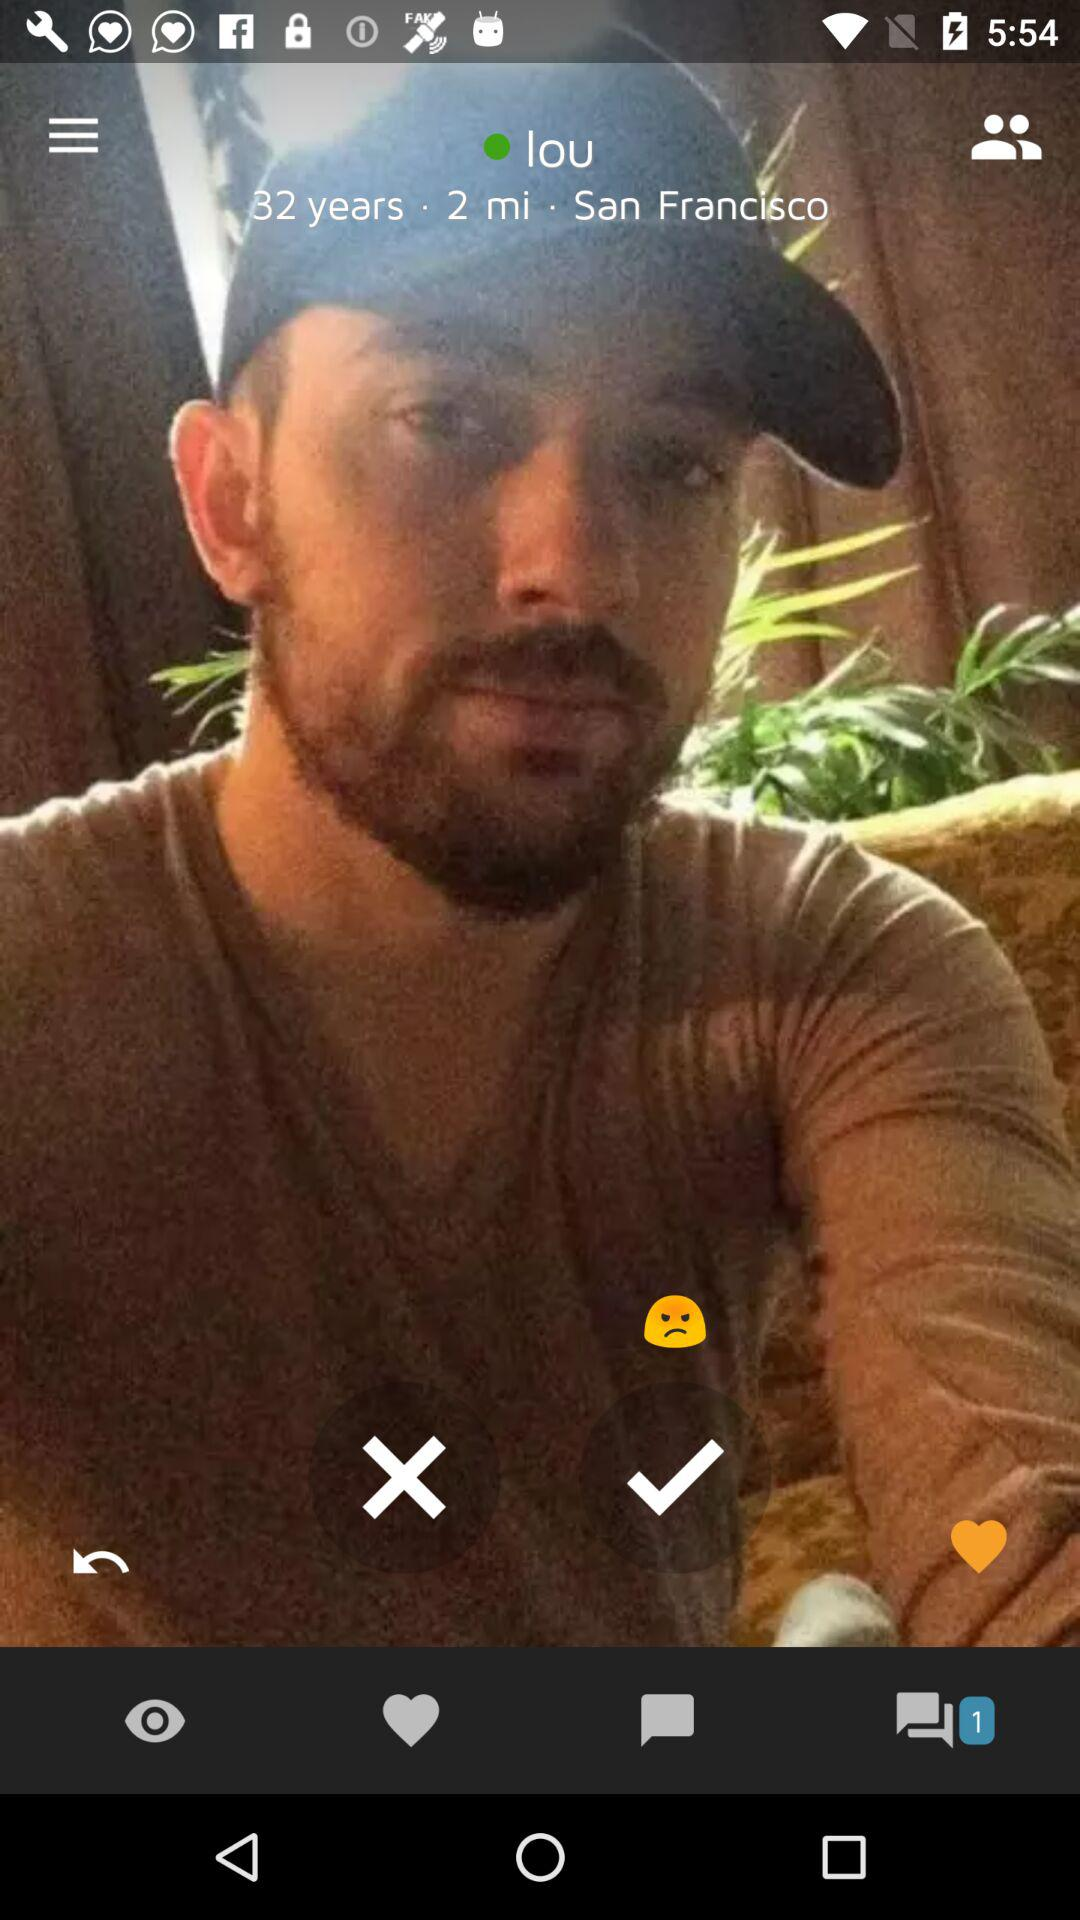How many messages are in the message box? There is 1 message in the message box. 